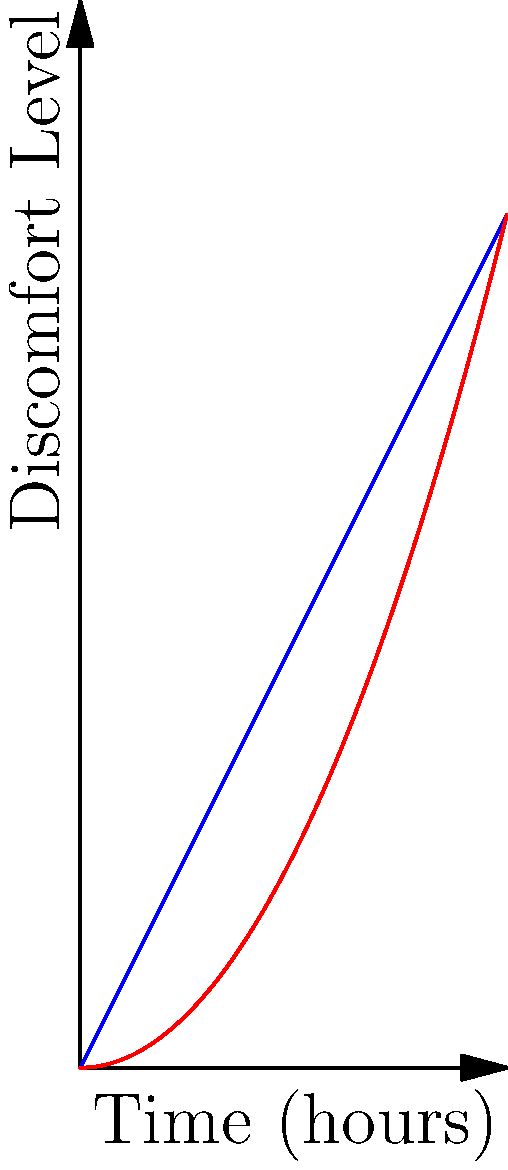The graph shows the discomfort level experienced by drivers over time in two different luxury car seat designs. Which seat design would you recommend for a long drive, and why? Consider the biomechanical implications on posture and comfort. To answer this question, let's analyze the graph step-by-step:

1. The blue line represents the standard seat, while the red line represents the luxury ergonomic seat.

2. For the standard seat (blue line):
   - The discomfort level increases linearly with time.
   - The function appears to be $f(x) = 2x$, where $x$ is time in hours.
   - After 4 hours, the discomfort level reaches 8 out of 10.

3. For the luxury ergonomic seat (red line):
   - The discomfort level increases non-linearly (quadratically) with time.
   - The function appears to be $f(x) = 0.5x^2$, where $x$ is time in hours.
   - After 4 hours, the discomfort level reaches 8 out of 10.

4. Biomechanical implications:
   - The standard seat causes discomfort to increase steadily, suggesting constant pressure on the same body parts.
   - The luxury ergonomic seat starts with lower discomfort and increases more slowly initially, indicating better weight distribution and support.
   - However, the luxury seat's discomfort accelerates over time, possibly due to the body adapting to the initial comfort and then experiencing fatigue.

5. For long drives:
   - In the first 2 hours, the luxury ergonomic seat clearly outperforms the standard seat.
   - After about 2.8 hours, both seats result in the same discomfort level.
   - Beyond this point, the standard seat actually performs better.

Considering these factors, for a long drive (over 3 hours), the standard seat would be recommended. It provides more consistent comfort over extended periods, which is crucial for maintaining good posture and reducing fatigue during long journeys.
Answer: Standard seat for long drives (>3 hours) due to more consistent long-term comfort. 